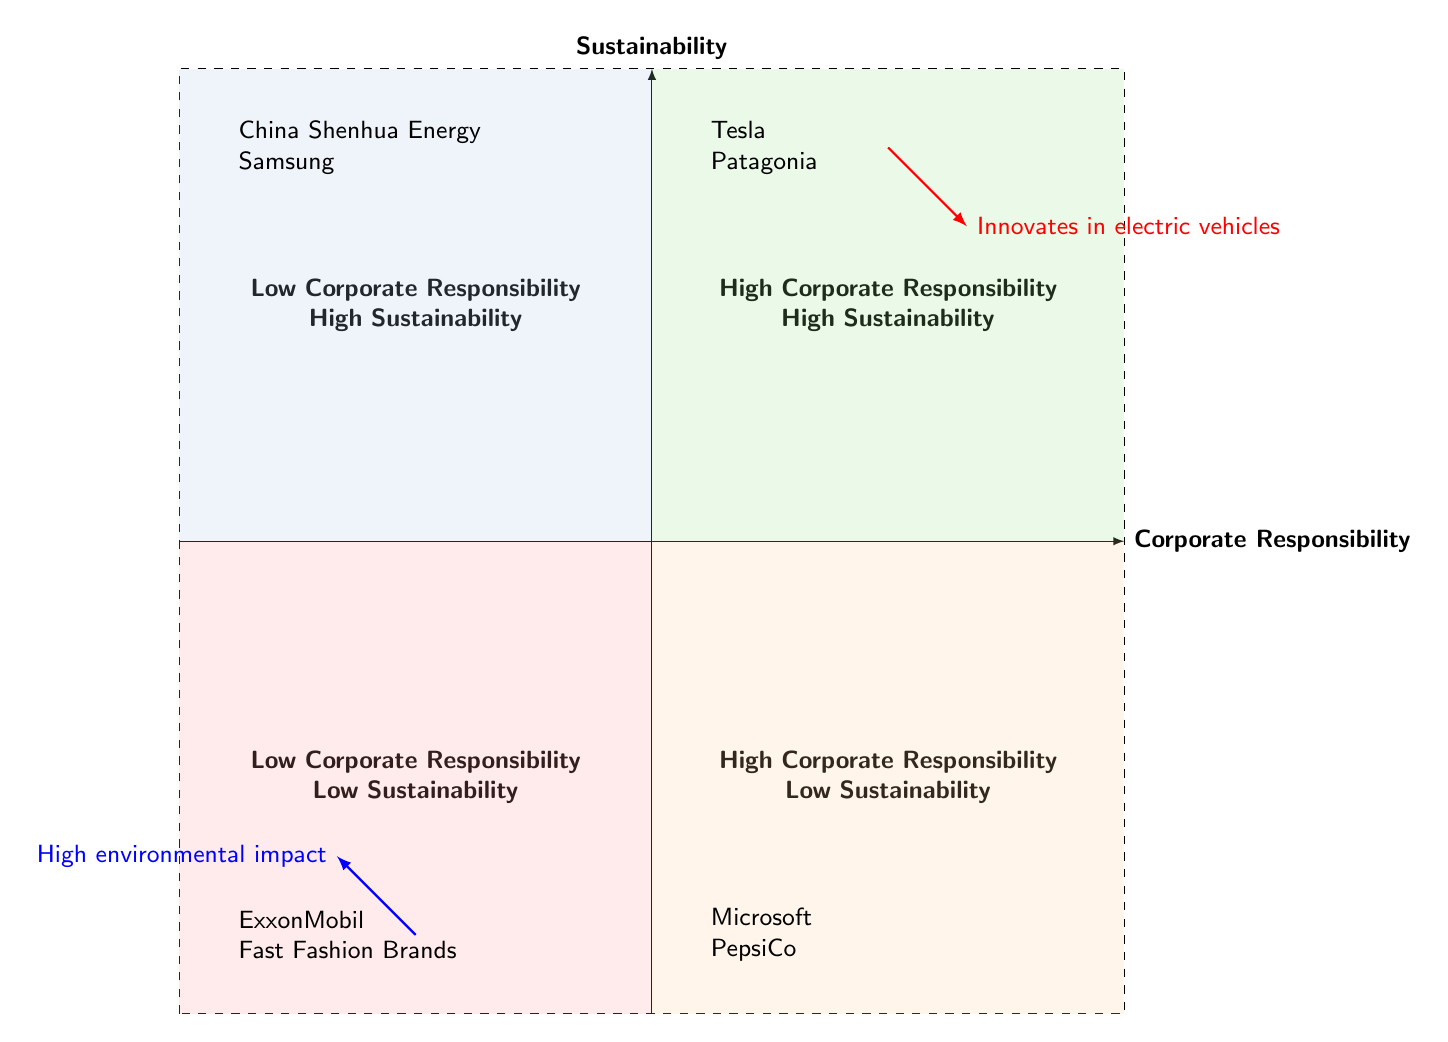What companies are in the High Corporate Responsibility - High Sustainability quadrant? This quadrant is in the upper right section of the chart. The companies listed here are Tesla and Patagonia, which are known for their high environmental responsibility and sustainable practices.
Answer: Tesla, Patagonia Which company is associated with high environmental impact despite having sustainable practices? The Low Corporate Responsibility - High Sustainability quadrant contains companies that, while they may engage in sustainable practices, do not demonstrate high corporate responsibility. China Shenhua Energy is one such example, as it is involved in renewable energy but criticized for governance issues.
Answer: China Shenhua Energy How many companies are in the Low Corporate Responsibility - Low Sustainability quadrant? This quadrant is located in the lower left section of the chart. There are two companies listed here: ExxonMobil and Fast Fashion Brands, making a total of two.
Answer: 2 What type of initiatives does Microsoft have? Located in the High Corporate Responsibility - Low Sustainability quadrant, Microsoft is known for having corporate social responsibility programs, even though it relies heavily on non-renewable energy.
Answer: Corporate social responsibility programs Which company is known for innovating in electric vehicles? In the High Corporate Responsibility - High Sustainability quadrant, Tesla is recognized for its innovations in electric vehicles and renewable energy solutions.
Answer: Tesla What are the companies in the Low Corporate Responsibility - High Sustainability quadrant criticized for? The companies listed here – China Shenhua Energy and Samsung – are noted for having sustainable practices but face criticism regarding social and governance issues, particularly around labor rights and governance.
Answer: Social and governance issues Which quadrant contains companies with both low corporate responsibility and low sustainability? The quadrant located in the bottom left of the diagram (Low Corporate Responsibility - Low Sustainability) specifically emphasizes companies that do poorly in both categories, such as ExxonMobil and Fast Fashion Brands.
Answer: Low Corporate Responsibility - Low Sustainability How does PepsiCo rate in terms of sustainability? PepsiCo is positioned in the High Corporate Responsibility - Low Sustainability quadrant, indicating it has some social welfare programs but still has a high carbon footprint, which negatively affects its sustainability rating.
Answer: High carbon footprint 